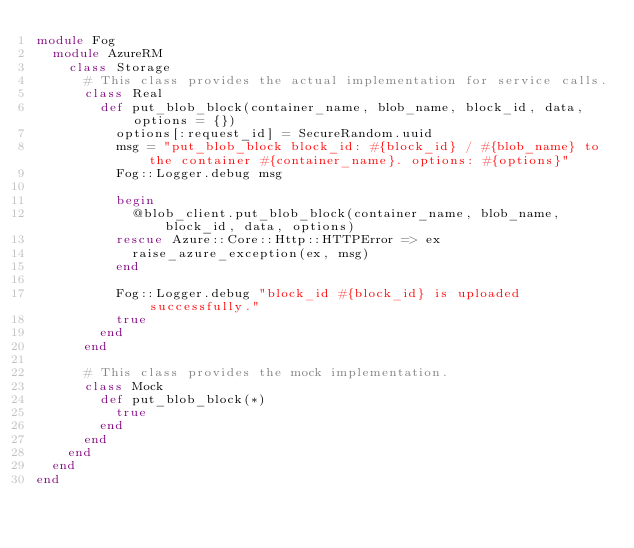Convert code to text. <code><loc_0><loc_0><loc_500><loc_500><_Ruby_>module Fog
  module AzureRM
    class Storage
      # This class provides the actual implementation for service calls.
      class Real
        def put_blob_block(container_name, blob_name, block_id, data, options = {})
          options[:request_id] = SecureRandom.uuid
          msg = "put_blob_block block_id: #{block_id} / #{blob_name} to the container #{container_name}. options: #{options}"
          Fog::Logger.debug msg

          begin
            @blob_client.put_blob_block(container_name, blob_name, block_id, data, options)
          rescue Azure::Core::Http::HTTPError => ex
            raise_azure_exception(ex, msg)
          end

          Fog::Logger.debug "block_id #{block_id} is uploaded successfully."
          true
        end
      end

      # This class provides the mock implementation.
      class Mock
        def put_blob_block(*)
          true
        end
      end
    end
  end
end
</code> 